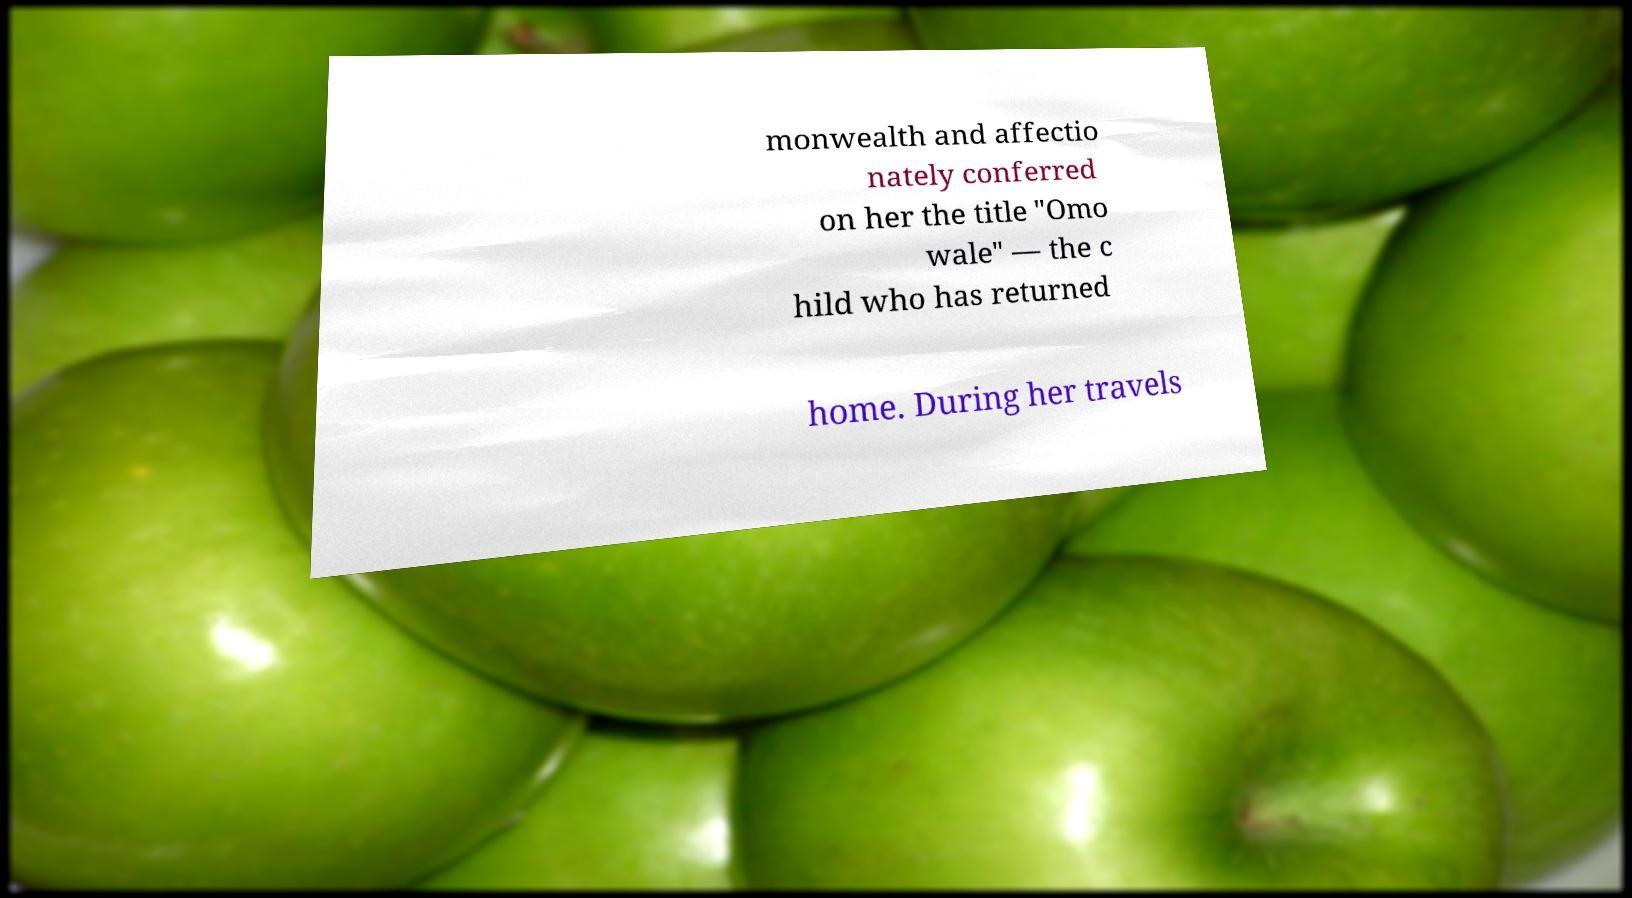What messages or text are displayed in this image? I need them in a readable, typed format. monwealth and affectio nately conferred on her the title "Omo wale" — the c hild who has returned home. During her travels 